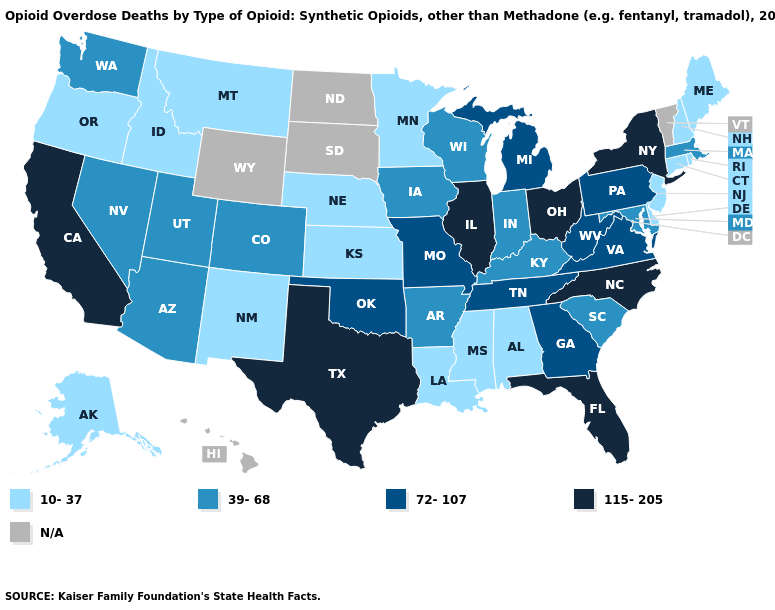Among the states that border California , does Oregon have the lowest value?
Be succinct. Yes. What is the value of Wisconsin?
Write a very short answer. 39-68. Which states have the lowest value in the USA?
Short answer required. Alabama, Alaska, Connecticut, Delaware, Idaho, Kansas, Louisiana, Maine, Minnesota, Mississippi, Montana, Nebraska, New Hampshire, New Jersey, New Mexico, Oregon, Rhode Island. Name the states that have a value in the range 72-107?
Write a very short answer. Georgia, Michigan, Missouri, Oklahoma, Pennsylvania, Tennessee, Virginia, West Virginia. What is the lowest value in states that border Ohio?
Give a very brief answer. 39-68. Which states have the lowest value in the Northeast?
Be succinct. Connecticut, Maine, New Hampshire, New Jersey, Rhode Island. Among the states that border Wisconsin , does Michigan have the highest value?
Be succinct. No. What is the value of South Dakota?
Keep it brief. N/A. What is the highest value in the USA?
Concise answer only. 115-205. Name the states that have a value in the range 115-205?
Give a very brief answer. California, Florida, Illinois, New York, North Carolina, Ohio, Texas. What is the lowest value in the West?
Be succinct. 10-37. Name the states that have a value in the range 72-107?
Keep it brief. Georgia, Michigan, Missouri, Oklahoma, Pennsylvania, Tennessee, Virginia, West Virginia. What is the value of Tennessee?
Be succinct. 72-107. 